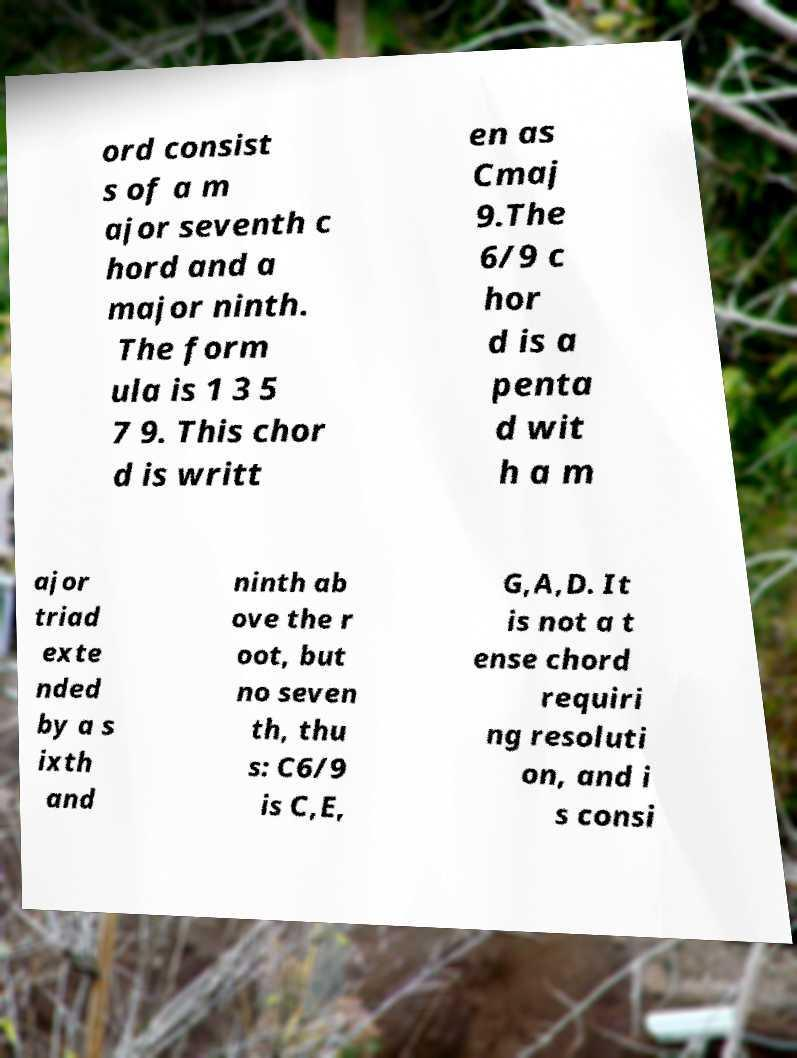Please read and relay the text visible in this image. What does it say? ord consist s of a m ajor seventh c hord and a major ninth. The form ula is 1 3 5 7 9. This chor d is writt en as Cmaj 9.The 6/9 c hor d is a penta d wit h a m ajor triad exte nded by a s ixth and ninth ab ove the r oot, but no seven th, thu s: C6/9 is C,E, G,A,D. It is not a t ense chord requiri ng resoluti on, and i s consi 